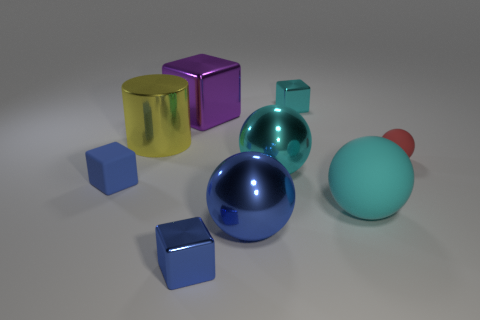Subtract all small cubes. How many cubes are left? 1 Add 1 small blue shiny cubes. How many objects exist? 10 Subtract all red spheres. How many spheres are left? 3 Subtract all spheres. How many objects are left? 5 Subtract all rubber blocks. Subtract all big metal cylinders. How many objects are left? 7 Add 8 big rubber things. How many big rubber things are left? 9 Add 7 tiny metallic objects. How many tiny metallic objects exist? 9 Subtract 0 yellow cubes. How many objects are left? 9 Subtract 3 blocks. How many blocks are left? 1 Subtract all red cubes. Subtract all red balls. How many cubes are left? 4 